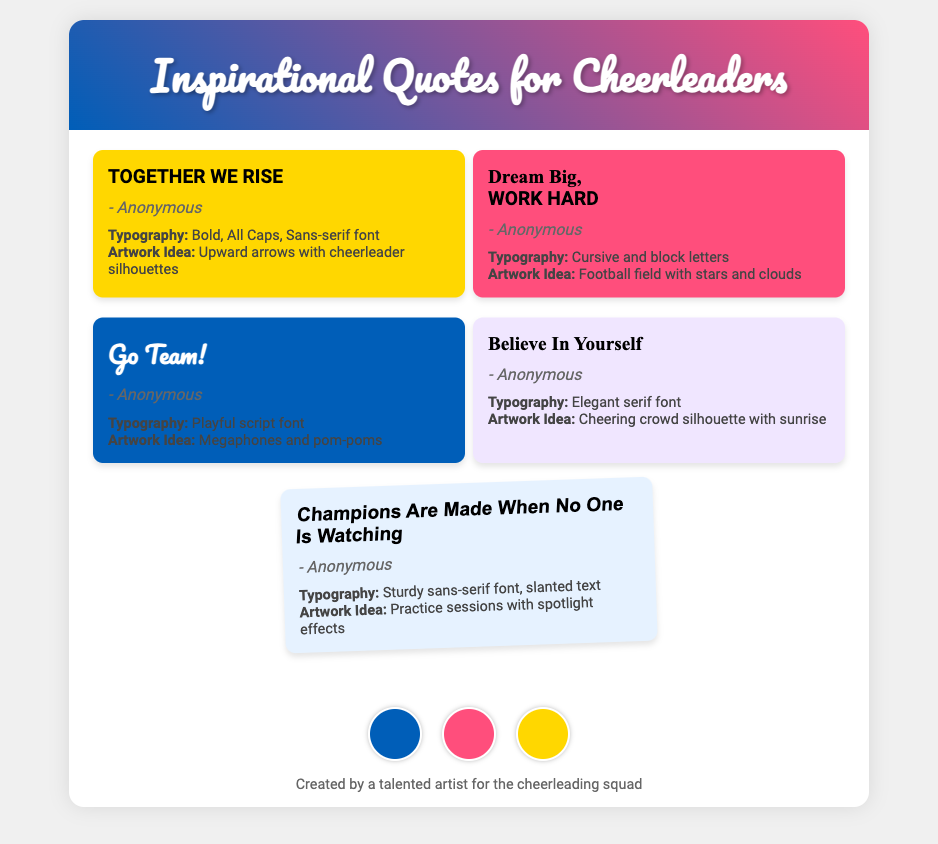What is the title of the document? The title is presented in the header section of the document.
Answer: Inspirational Quotes for Cheerleaders How many quotes are featured in the document? The document contains a total of five quotes displayed in separate cards.
Answer: 5 What is the background color of the quote "TOGETHER WE RISE"? The background color for this quote is mentioned within its card styling.
Answer: #FFD700 Which typography style is used for "Go Team!"? The typography style for this quote is noted in the quote card description.
Answer: Playful script font What artwork idea is suggested for "Believe In Yourself"? The artwork idea is included in the quote card details.
Answer: Cheering crowd silhouette with sunrise How is the quote "Champions Are Made When No One Is Watching" styled? The styling includes slanted text as indicated in the document.
Answer: Sturdy sans-serif font, slanted text What is the color of the "Pom-Pom Pink" swatch? The color name corresponds to one of the color swatches in the footer.
Answer: #FF4E7C Who is credited with creating the document? The creator is mentioned in the footer area of the document.
Answer: A talented artist for the cheerleading squad 